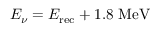Convert formula to latex. <formula><loc_0><loc_0><loc_500><loc_500>E _ { \nu } = E _ { r e c } + 1 . 8 M e V</formula> 